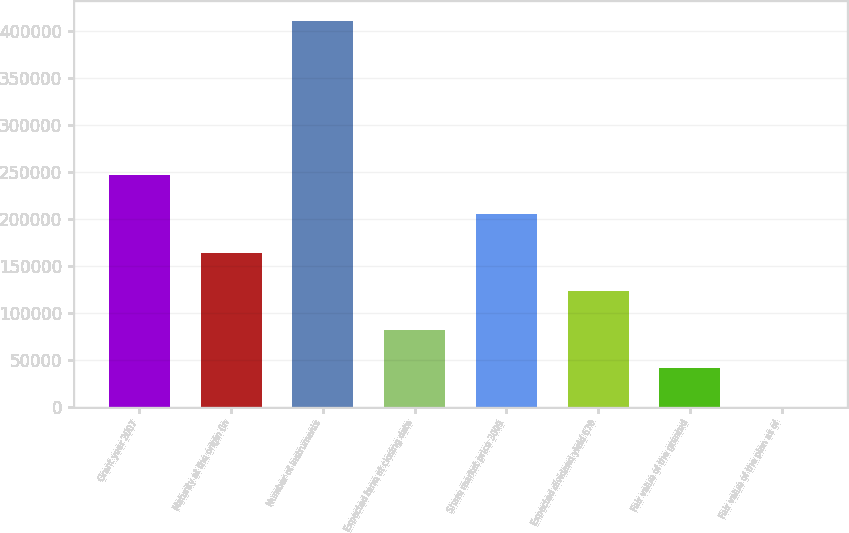Convert chart to OTSL. <chart><loc_0><loc_0><loc_500><loc_500><bar_chart><fcel>Grant year 2007<fcel>Maturity at the origin (in<fcel>Number of instruments<fcel>Expected term at closing date<fcel>Share market price 3009<fcel>Expected dividend yield 670<fcel>Fair value of the granted<fcel>Fair value of the plan as of<nl><fcel>246240<fcel>164161<fcel>410400<fcel>82080.7<fcel>205200<fcel>123121<fcel>41040.8<fcel>0.9<nl></chart> 